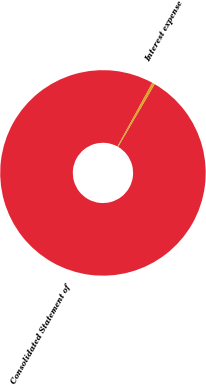<chart> <loc_0><loc_0><loc_500><loc_500><pie_chart><fcel>Consolidated Statement of<fcel>Interest expense<nl><fcel>99.57%<fcel>0.43%<nl></chart> 